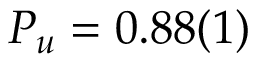<formula> <loc_0><loc_0><loc_500><loc_500>P _ { u } = 0 . 8 8 ( 1 )</formula> 